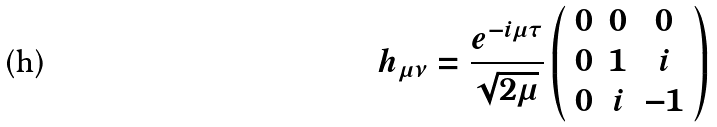<formula> <loc_0><loc_0><loc_500><loc_500>h _ { \mu \nu } = \frac { e ^ { - i \mu \tau } } { \sqrt { 2 \mu } } \left ( \begin{array} { c c c } 0 & 0 & 0 \\ 0 & 1 & i \\ 0 & i & - 1 \\ \end{array} \right )</formula> 